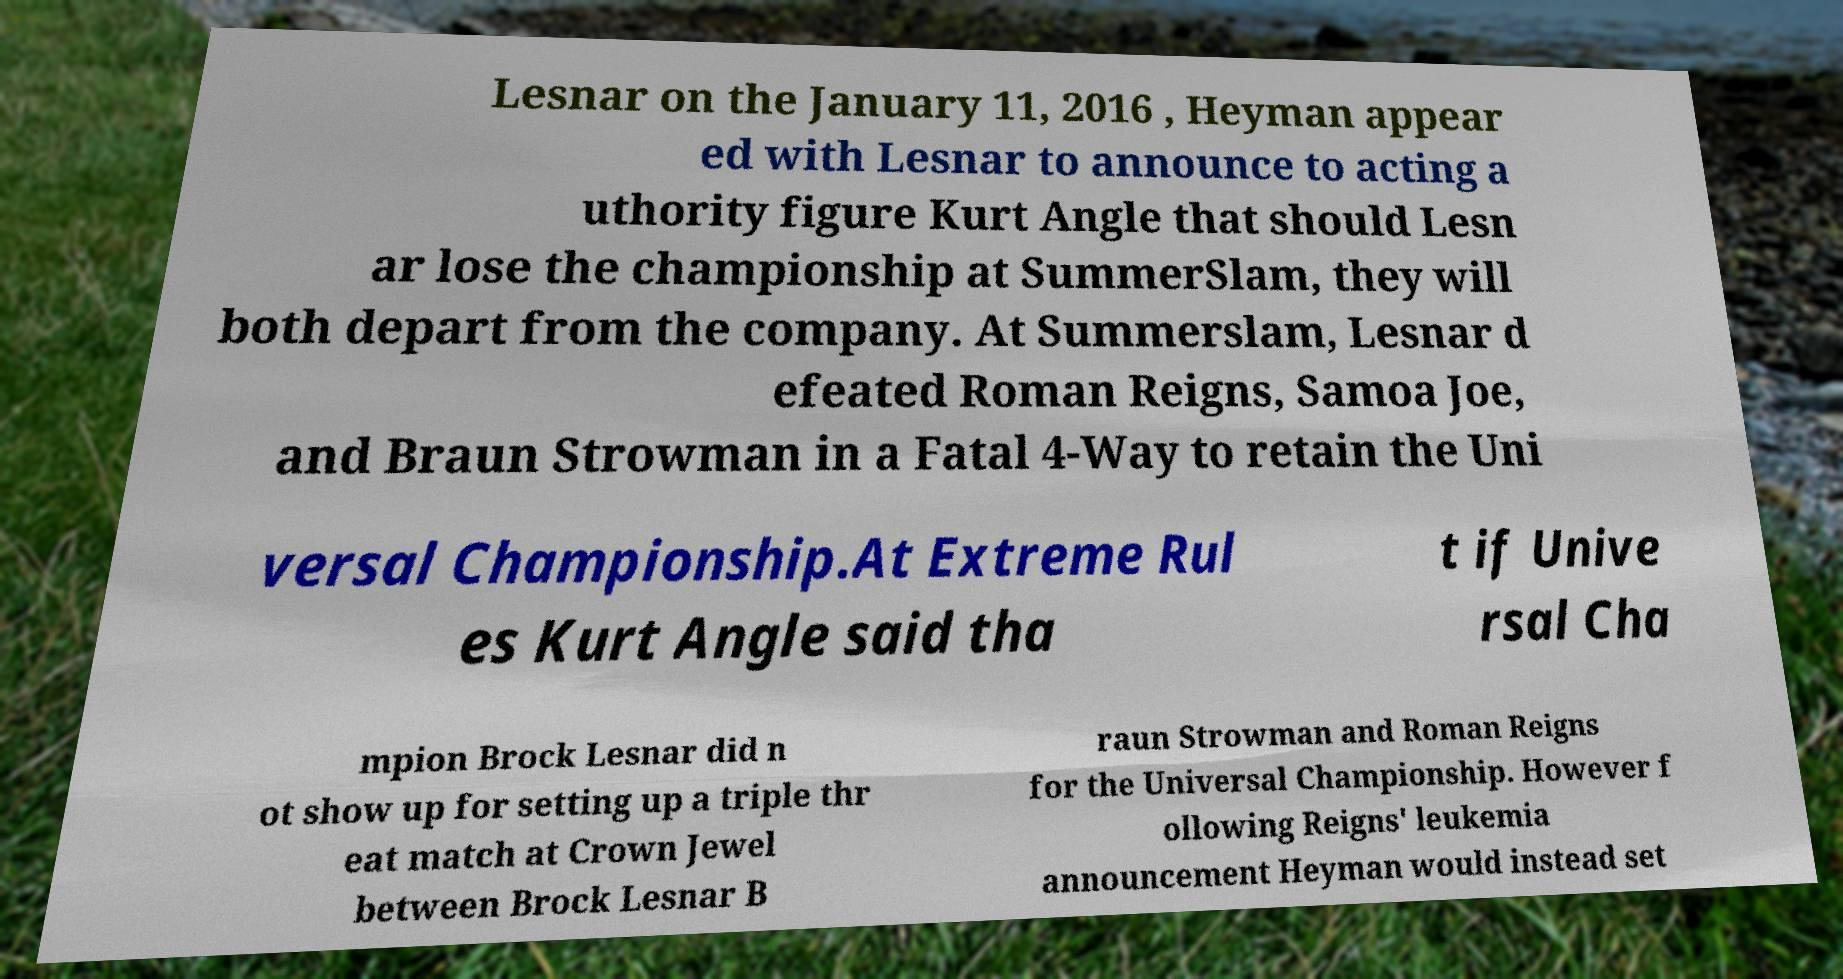Can you read and provide the text displayed in the image?This photo seems to have some interesting text. Can you extract and type it out for me? Lesnar on the January 11, 2016 , Heyman appear ed with Lesnar to announce to acting a uthority figure Kurt Angle that should Lesn ar lose the championship at SummerSlam, they will both depart from the company. At Summerslam, Lesnar d efeated Roman Reigns, Samoa Joe, and Braun Strowman in a Fatal 4-Way to retain the Uni versal Championship.At Extreme Rul es Kurt Angle said tha t if Unive rsal Cha mpion Brock Lesnar did n ot show up for setting up a triple thr eat match at Crown Jewel between Brock Lesnar B raun Strowman and Roman Reigns for the Universal Championship. However f ollowing Reigns' leukemia announcement Heyman would instead set 